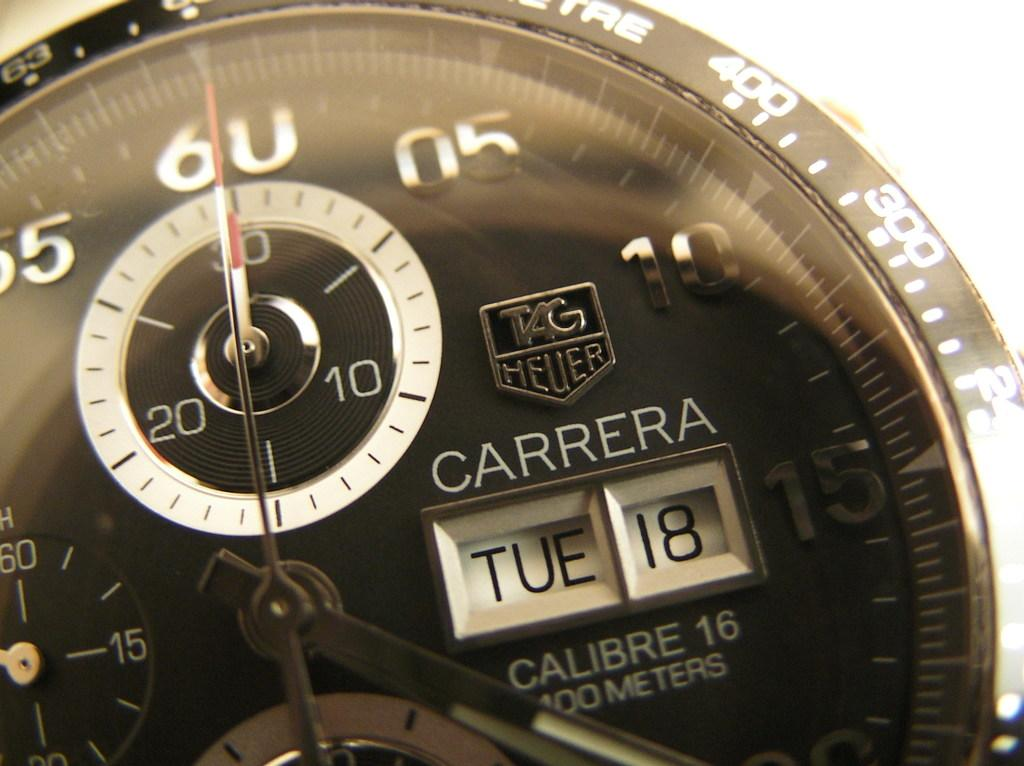<image>
Render a clear and concise summary of the photo. Carrera watch shows that it is Tue 18th. 